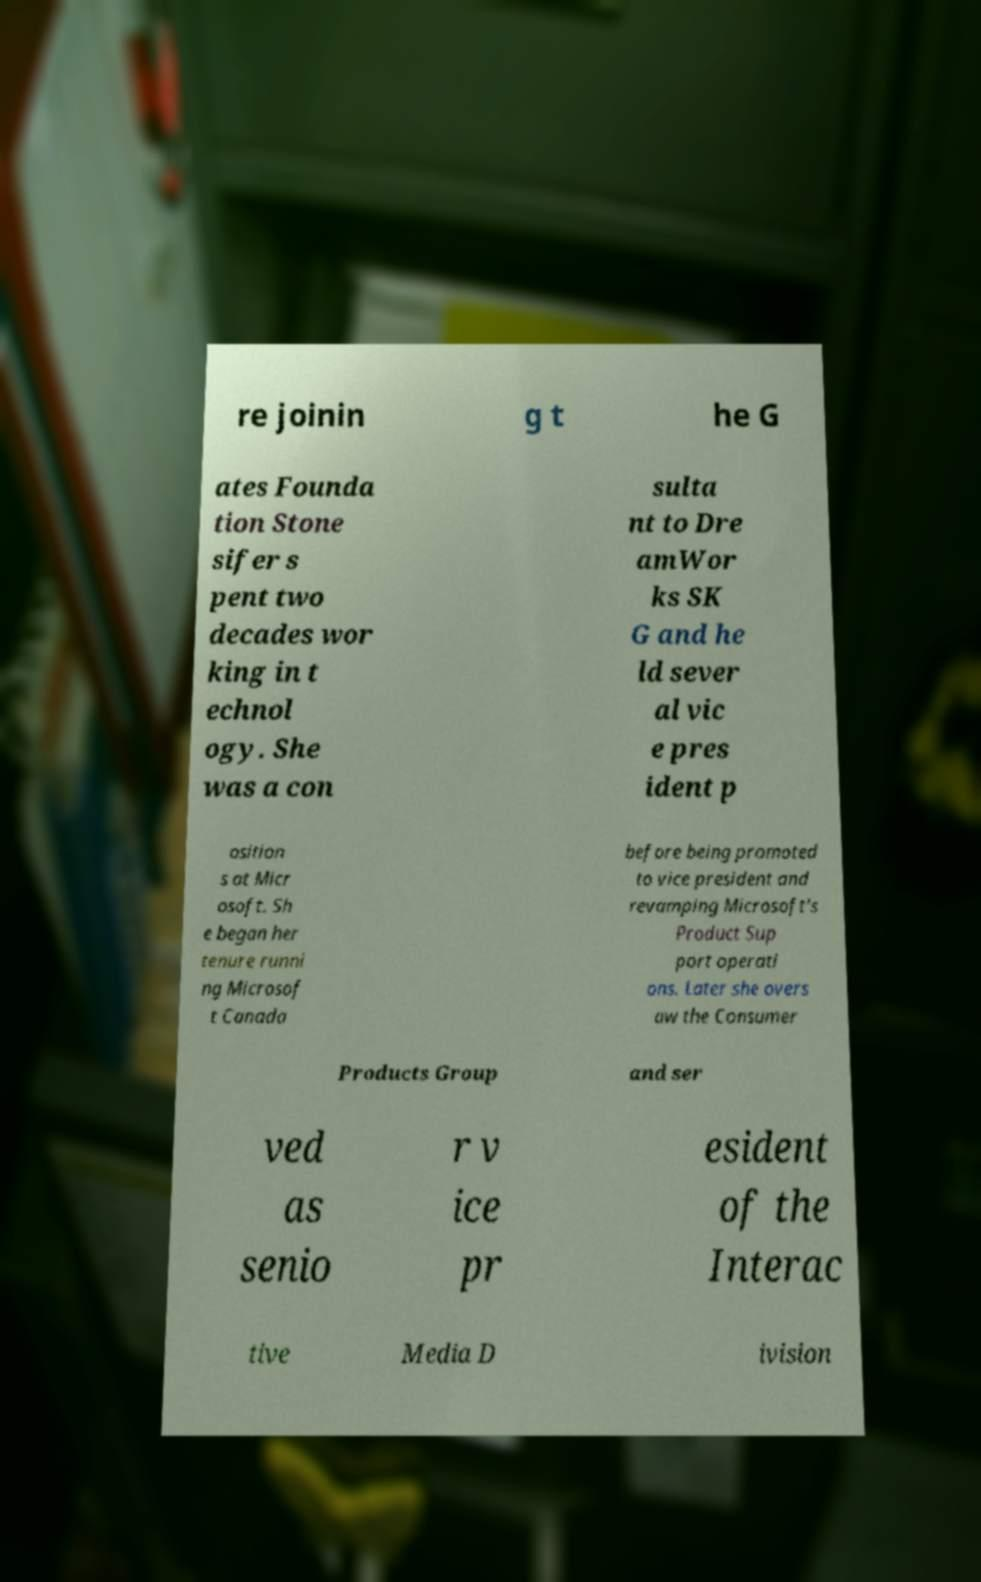Can you read and provide the text displayed in the image?This photo seems to have some interesting text. Can you extract and type it out for me? re joinin g t he G ates Founda tion Stone sifer s pent two decades wor king in t echnol ogy. She was a con sulta nt to Dre amWor ks SK G and he ld sever al vic e pres ident p osition s at Micr osoft. Sh e began her tenure runni ng Microsof t Canada before being promoted to vice president and revamping Microsoft's Product Sup port operati ons. Later she overs aw the Consumer Products Group and ser ved as senio r v ice pr esident of the Interac tive Media D ivision 